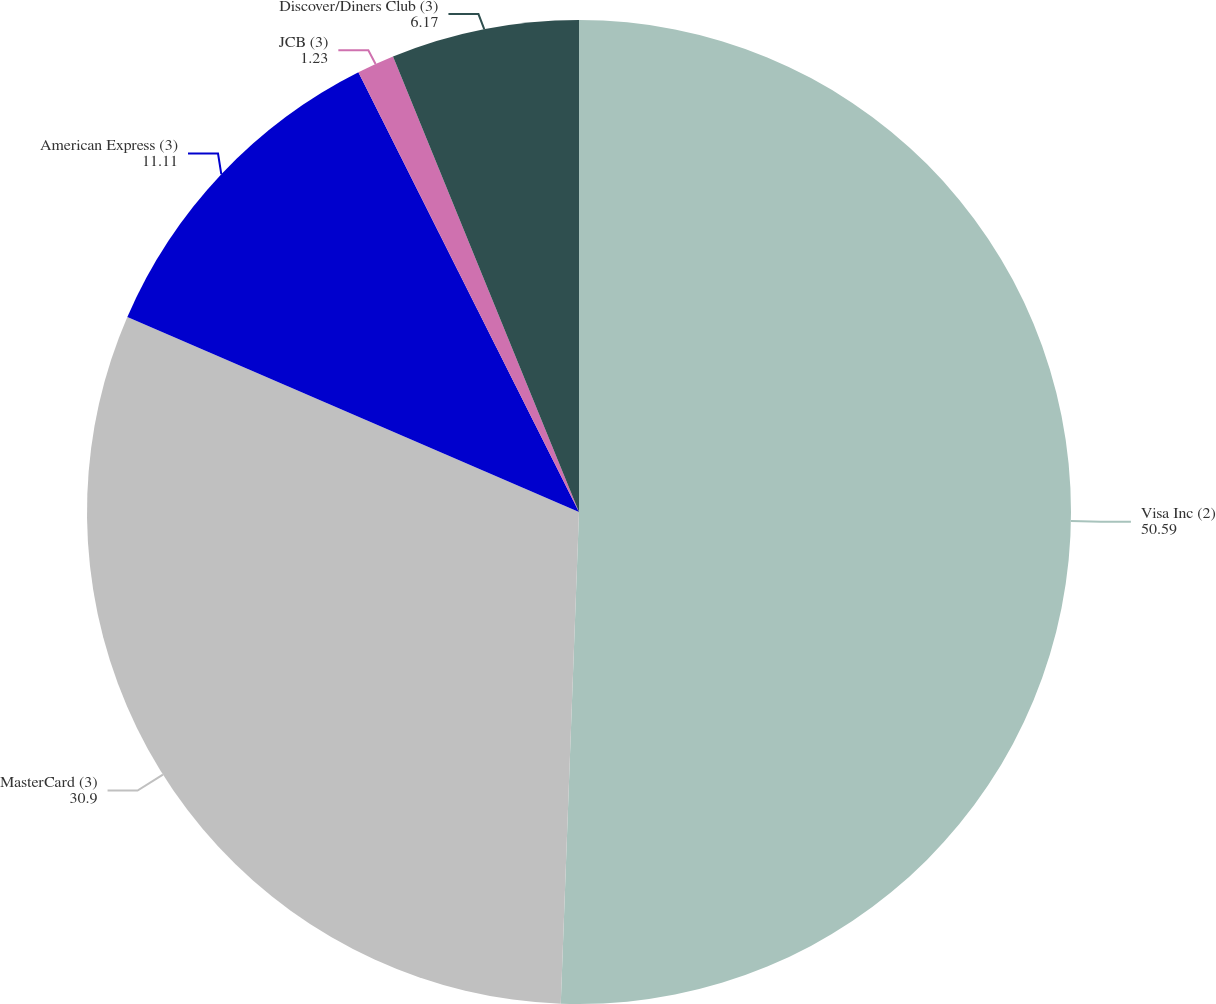Convert chart to OTSL. <chart><loc_0><loc_0><loc_500><loc_500><pie_chart><fcel>Visa Inc (2)<fcel>MasterCard (3)<fcel>American Express (3)<fcel>JCB (3)<fcel>Discover/Diners Club (3)<nl><fcel>50.59%<fcel>30.9%<fcel>11.11%<fcel>1.23%<fcel>6.17%<nl></chart> 